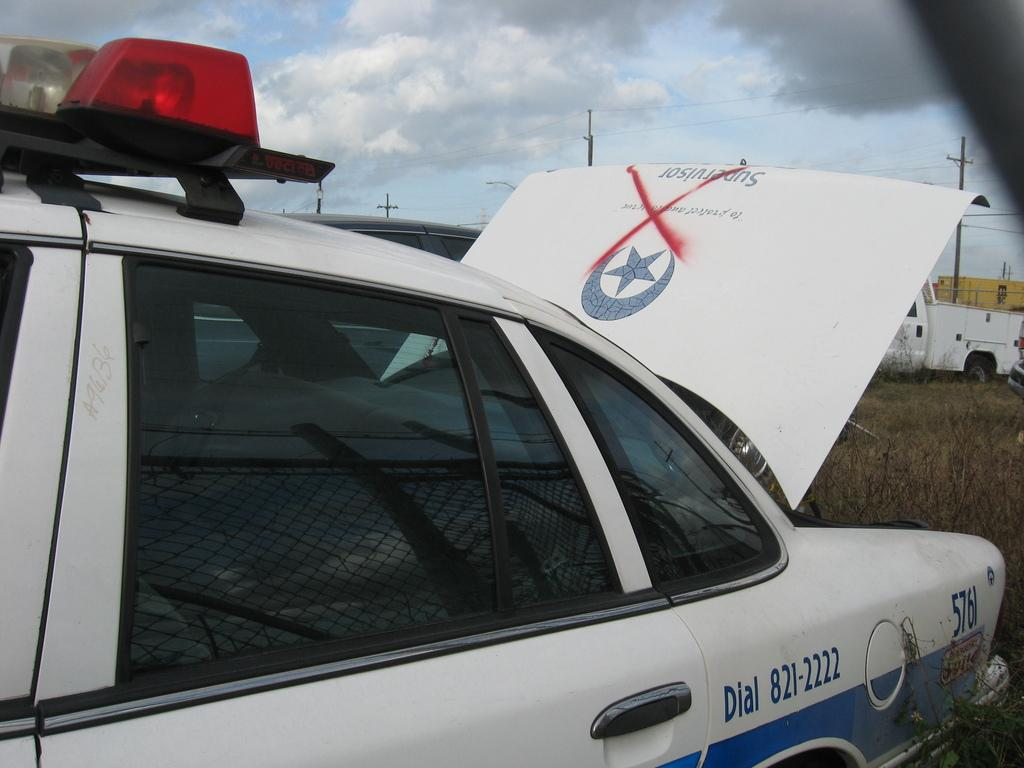Provide a one-sentence caption for the provided image. Police car 576 sits with the trunk open and a red x painted on it. 